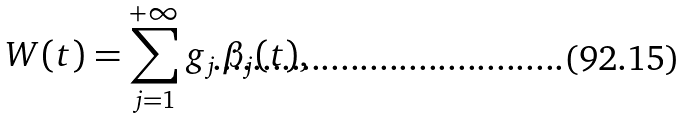<formula> <loc_0><loc_0><loc_500><loc_500>W ( t ) = \sum _ { j = 1 } ^ { + \infty } g _ { j } \, \beta _ { j } ( t ) ,</formula> 